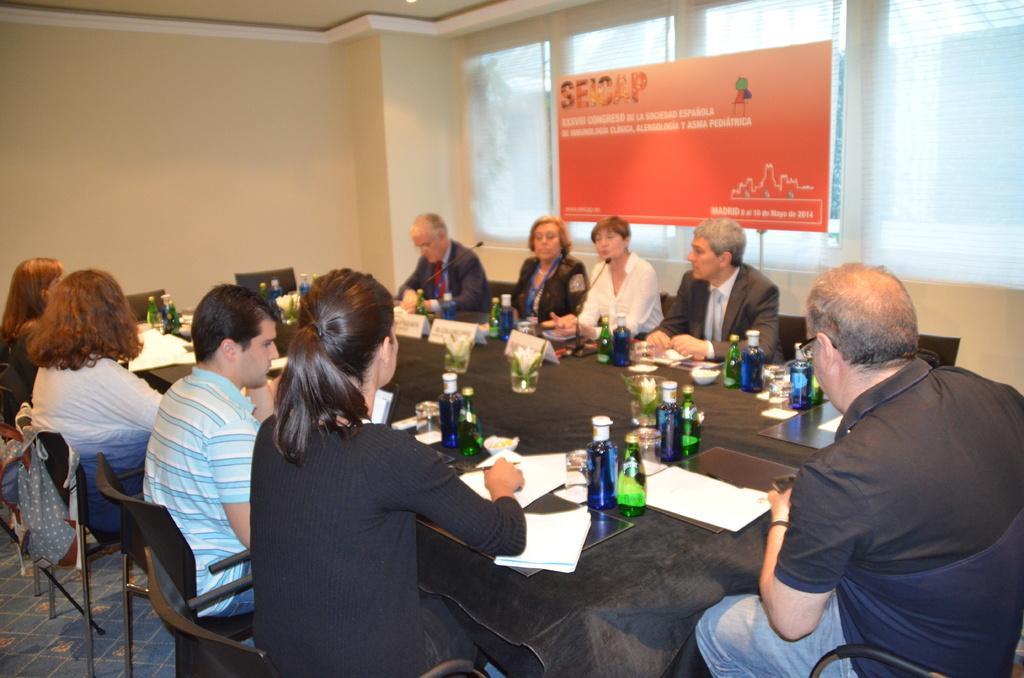How would you summarize this image in a sentence or two? There are few people sitting on the chair at the table. On the table there are bottles,glasses,papers and microphones. In the background there is a wall,window and a hoarding. 